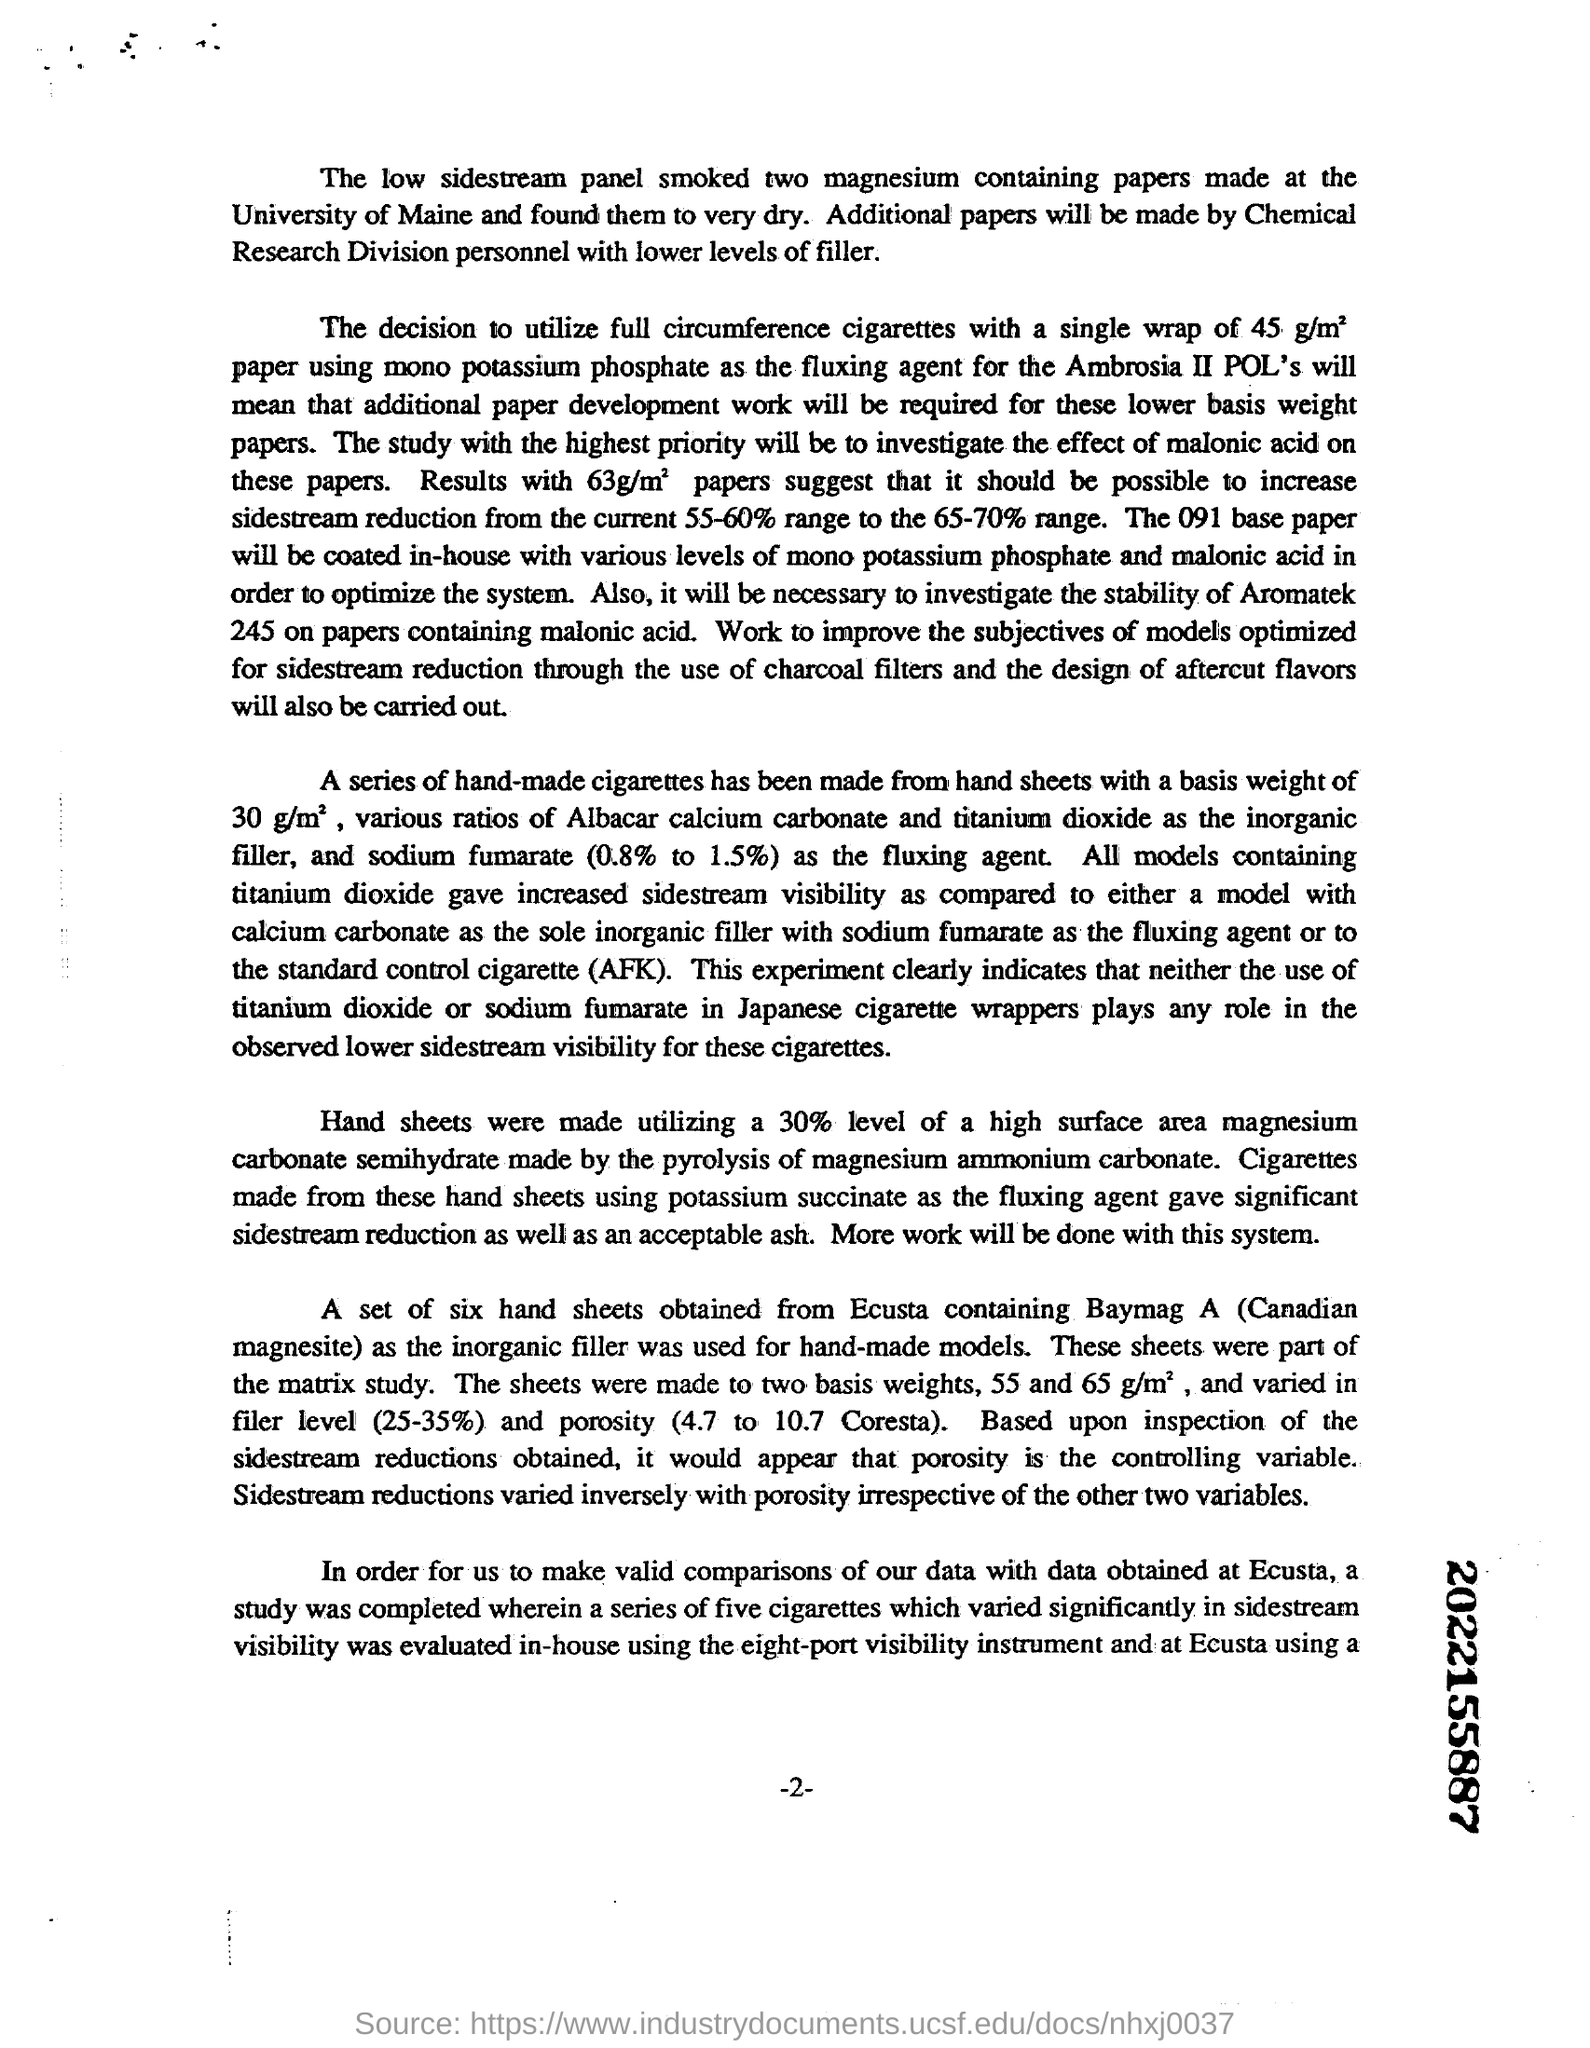Where were the two magnesium containing  papers made at?
Keep it short and to the point. University of Maine. Which base paper will be coated in-house with various levels of mono potassium phosphate and malonic acid in order to optimize the system?
Your answer should be very brief. 091. Hand sheets were made utilizing a 30% level of which component?
Provide a short and direct response. High surface area magnesium carbonate semihydrate made by the pyrolysis of magnesium ammonium carbonate. 